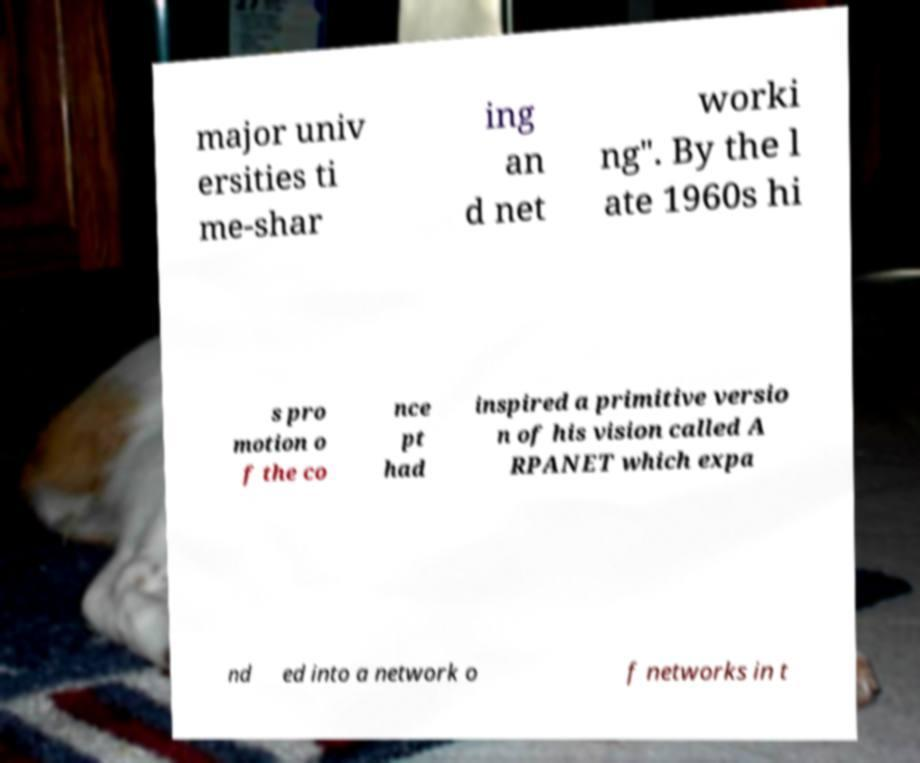Can you read and provide the text displayed in the image?This photo seems to have some interesting text. Can you extract and type it out for me? major univ ersities ti me-shar ing an d net worki ng". By the l ate 1960s hi s pro motion o f the co nce pt had inspired a primitive versio n of his vision called A RPANET which expa nd ed into a network o f networks in t 